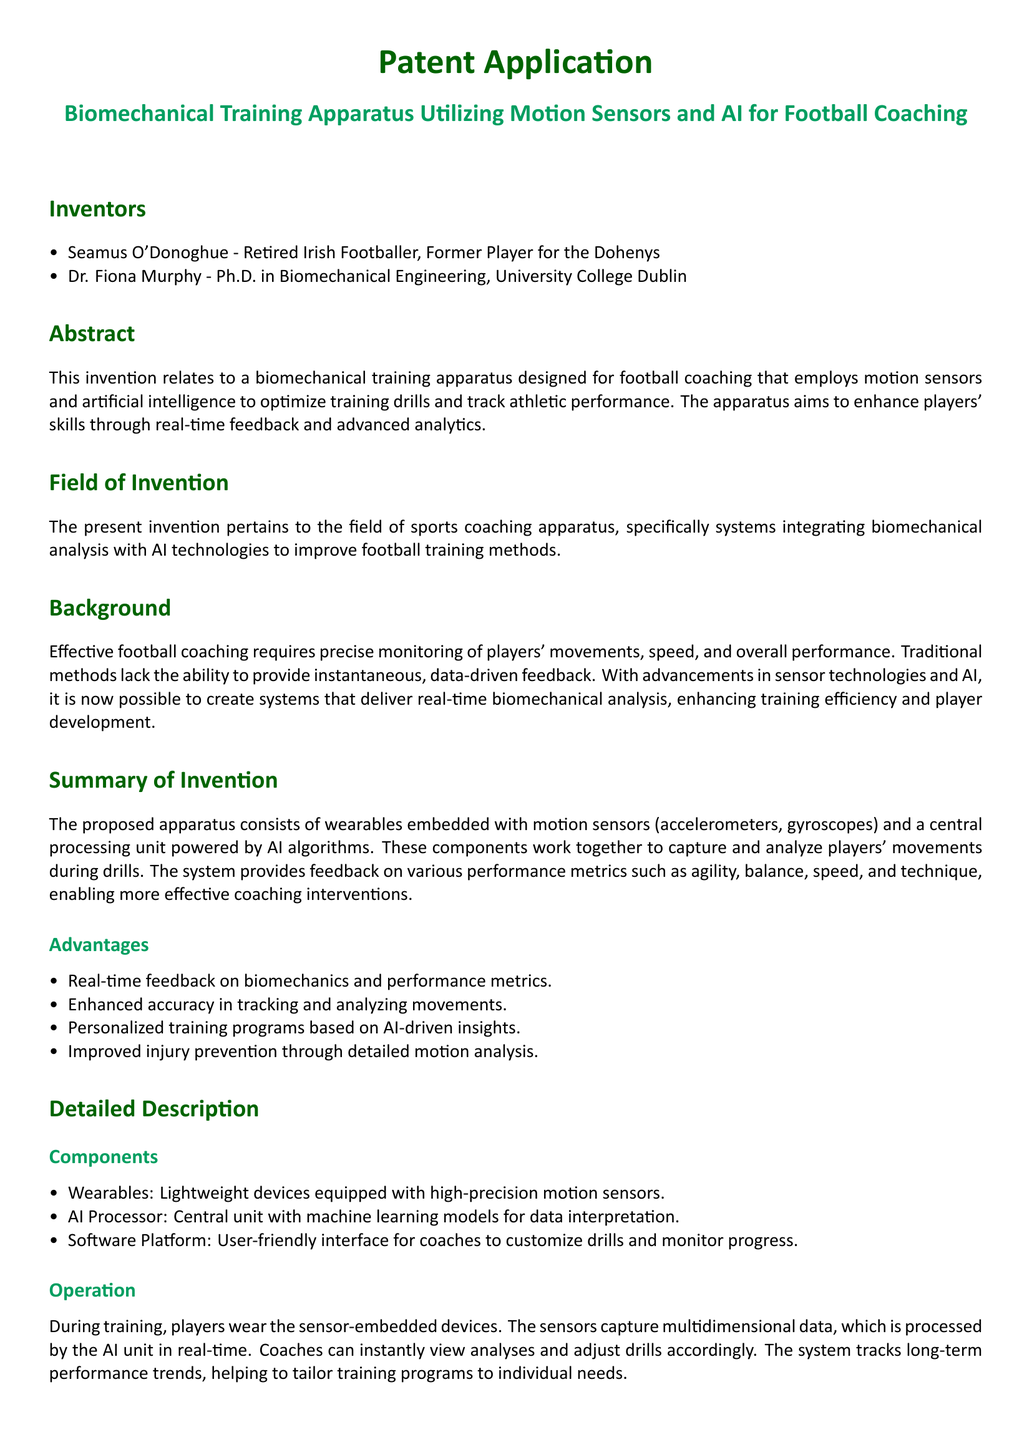What is the name of the first inventor? The first inventor listed in the document is Seamus O'Donoghue.
Answer: Seamus O'Donoghue What institution is Dr. Fiona Murphy affiliated with? Dr. Fiona Murphy is affiliated with University College Dublin.
Answer: University College Dublin What are the two types of motion sensors mentioned? The document specifies accelerometers and gyroscopes as the types of motion sensors used.
Answer: accelerometers and gyroscopes What is one key advantage of the proposed training apparatus? One key advantage mentioned is real-time feedback on biomechanics and performance metrics.
Answer: real-time feedback What does the AI processor use to offer personalized feedback? The AI processor utilizes machine learning algorithms for providing feedback and training recommendations.
Answer: machine learning algorithms How does the proposed apparatus aim to enhance players' skills? The apparatus aims to enhance skills through real-time feedback and advanced analytics.
Answer: real-time feedback and advanced analytics What is the purpose of the software platform in the apparatus? The software platform is designed to help coaches customize drills and monitor player progress.
Answer: customize drills and monitor progress 